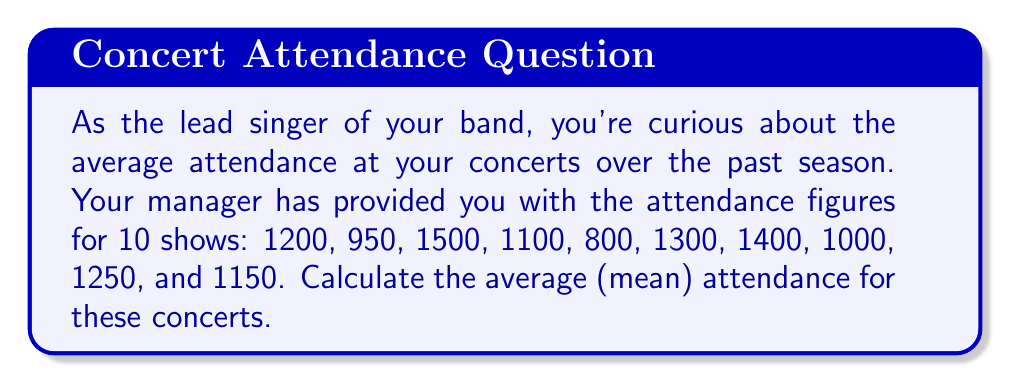Can you solve this math problem? To calculate the average (mean) attendance, we need to follow these steps:

1. Sum up all the attendance figures:
   $$\text{Total Attendance} = 1200 + 950 + 1500 + 1100 + 800 + 1300 + 1400 + 1000 + 1250 + 1150$$

2. Count the number of concerts:
   $$\text{Number of Concerts} = 10$$

3. Apply the formula for the arithmetic mean:
   $$\text{Average Attendance} = \frac{\text{Total Attendance}}{\text{Number of Concerts}}$$

Let's perform the calculations:

1. Sum of attendance:
   $$\text{Total Attendance} = 11650$$

2. Number of concerts is already given as 10.

3. Applying the formula:
   $$\text{Average Attendance} = \frac{11650}{10} = 1165$$

Therefore, the average attendance at your concerts over the season was 1165 people.
Answer: The average attendance at the concerts over the season was 1165 people. 